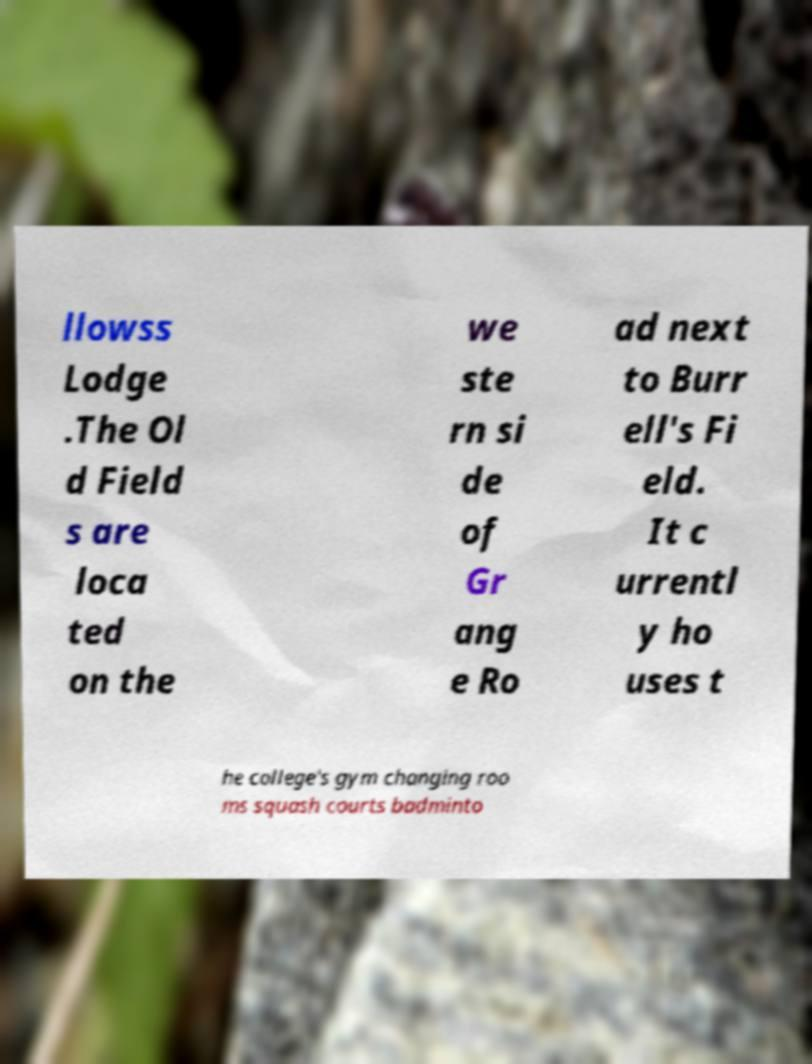Can you accurately transcribe the text from the provided image for me? llowss Lodge .The Ol d Field s are loca ted on the we ste rn si de of Gr ang e Ro ad next to Burr ell's Fi eld. It c urrentl y ho uses t he college's gym changing roo ms squash courts badminto 